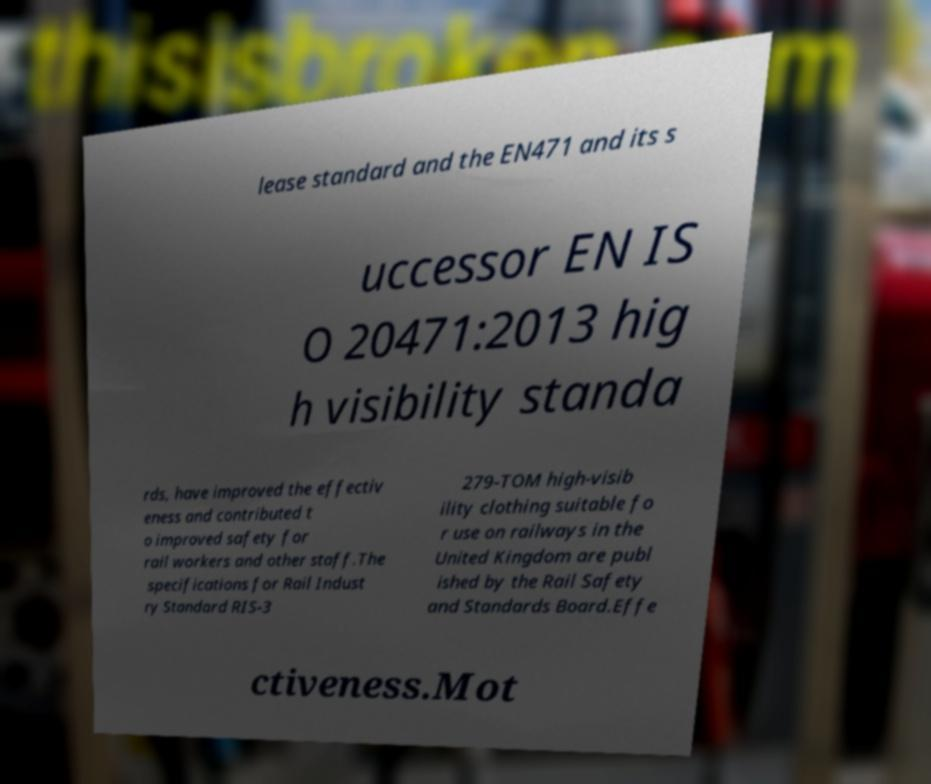Please identify and transcribe the text found in this image. lease standard and the EN471 and its s uccessor EN IS O 20471:2013 hig h visibility standa rds, have improved the effectiv eness and contributed t o improved safety for rail workers and other staff.The specifications for Rail Indust ry Standard RIS-3 279-TOM high-visib ility clothing suitable fo r use on railways in the United Kingdom are publ ished by the Rail Safety and Standards Board.Effe ctiveness.Mot 